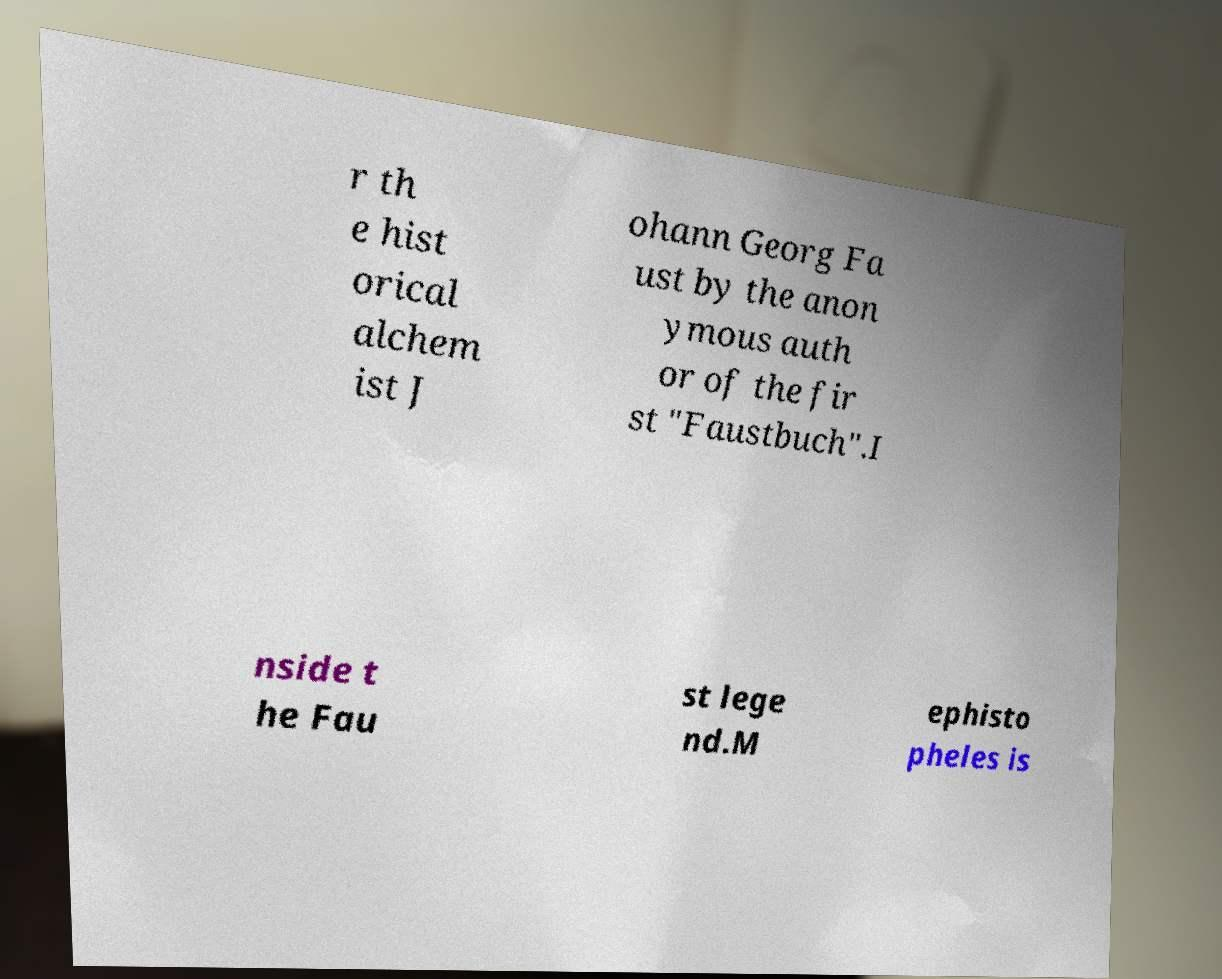Can you read and provide the text displayed in the image?This photo seems to have some interesting text. Can you extract and type it out for me? r th e hist orical alchem ist J ohann Georg Fa ust by the anon ymous auth or of the fir st "Faustbuch".I nside t he Fau st lege nd.M ephisto pheles is 